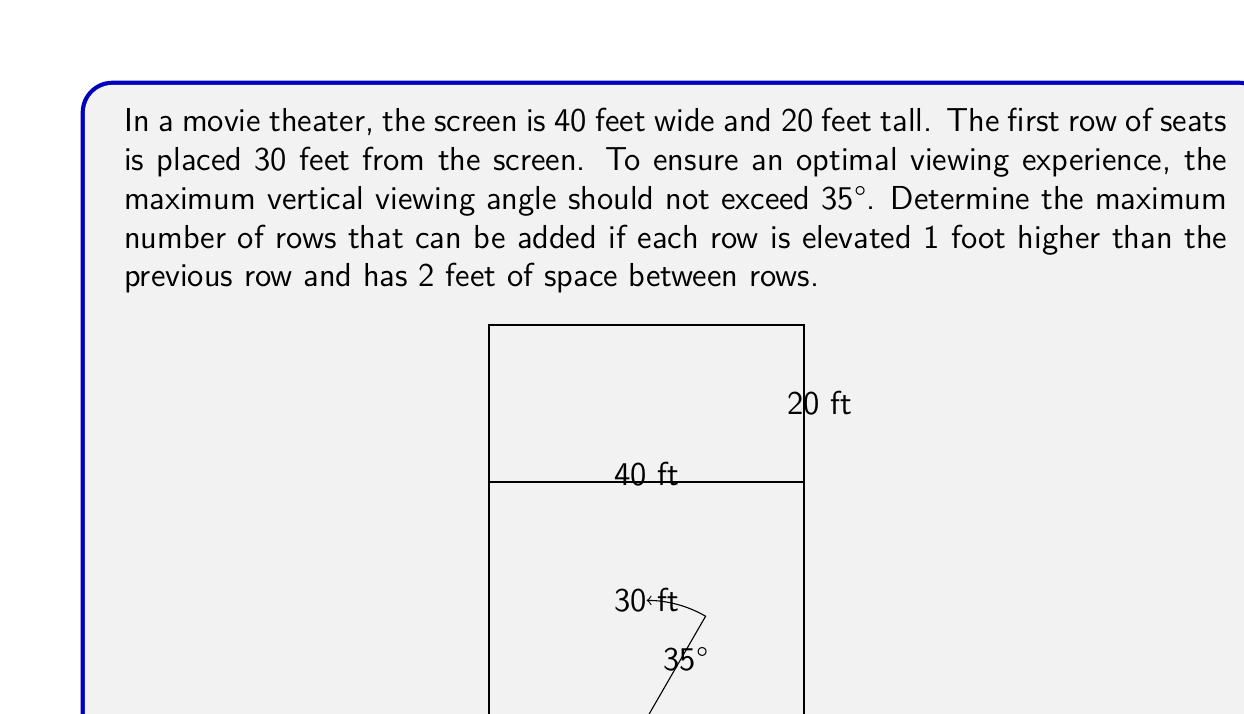Can you answer this question? To solve this problem, we need to use trigonometry and the properties of similar triangles. Let's approach this step-by-step:

1) First, we need to find the height at which the 35° angle intersects the top of the screen. We can use the tangent function for this:

   $$\tan(35°) = \frac{\text{opposite}}{\text{adjacent}} = \frac{h}{30}$$

   Where $h$ is the height above eye level where the line of sight intersects the screen.

2) Solving for $h$:

   $$h = 30 \tan(35°) \approx 21.0 \text{ feet}$$

3) The total height from the floor to this point is 21 feet plus the eye level height. Assuming the average eye level is about 4 feet when seated:

   $$\text{Total height} = 21 + 4 = 25 \text{ feet}$$

4) Now, we need to determine how many 1-foot elevations we can fit in this 25-foot height:

   $$\text{Number of elevations} = 25 - 4 = 21$$

5) However, we also need to account for the 2 feet of space between each row. Each additional row requires 3 feet (1 foot elevation + 2 feet space). We can set up the inequality:

   $$3x \leq 21$$

   Where $x$ is the number of additional rows.

6) Solving for $x$:

   $$x \leq 7$$

Therefore, the maximum number of additional rows is 7.
Answer: The maximum number of rows that can be added is 7. 